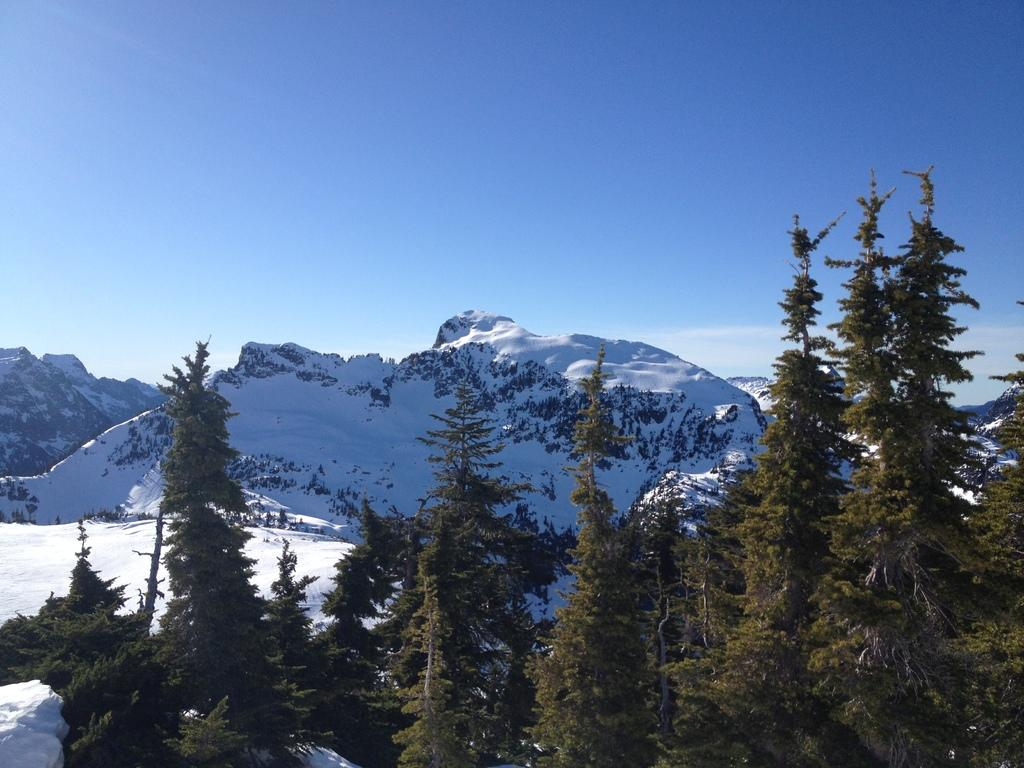What type of natural features can be seen in the image? There are trees and mountains visible in the image. What is the weather like in the image? There is snow visible in the image, which suggests a cold or snowy environment. What part of the natural environment is visible in the image? The sky is visible in the image. Where might this image have been taken? The image may have been taken near the mountains, given their prominence in the image. What type of tax is being discussed by the crows in the image? There are no crows present in the image, so it is not possible to determine if they are discussing any tax. 